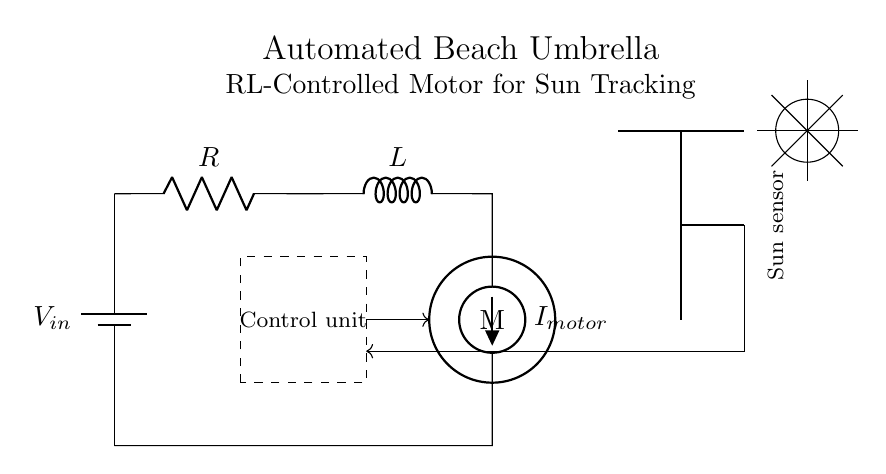What is the value of the resistor? The circuit diagram displays a resistor labeled as R, but it does not specify its value numerically. The answer is not directly visible.
Answer: Not specified What type of current is supplied to the motor? The motor in the circuit is powered by an American current source labeled I_motor. The current can be either direct or alternating, but the specific type is not indicated in the diagram.
Answer: American current source What is the function of the control unit? The control unit is a dashed rectangle labeled as such in the diagram, indicating that it processes signals from the sensor and manages the RL circuit operation. Its specific function in terms of control logic isn't detailed in the visual representation.
Answer: Control logic What component is responsible for sun-tracking? The sun sensor is visually represented as an active component and is positioned near the top of the diagram, indicating its role in detecting sunlight to track the sun and adjust the umbrella accordingly.
Answer: Sun sensor How many main components are in the RL circuit? The circuit diagram lists three main components: a resistor, an inductor, and an electric motor, which work together to control the movement of the umbrella.
Answer: Three What is the role of the inductor in this circuit? The inductor in an RL circuit is typically used to store energy in a magnetic field and affects the timing of current changes in the circuit. It smooths out fluctuations, thereby providing stability to the operation of the motor.
Answer: Energy storage What does the sun represent in this diagram? The sun is depicted as a circle with rays extending outward in the diagram, symbolizing the light source that the sun sensor detects to enable the umbrella to adjust its position based on the sun's location in the sky.
Answer: Light source 